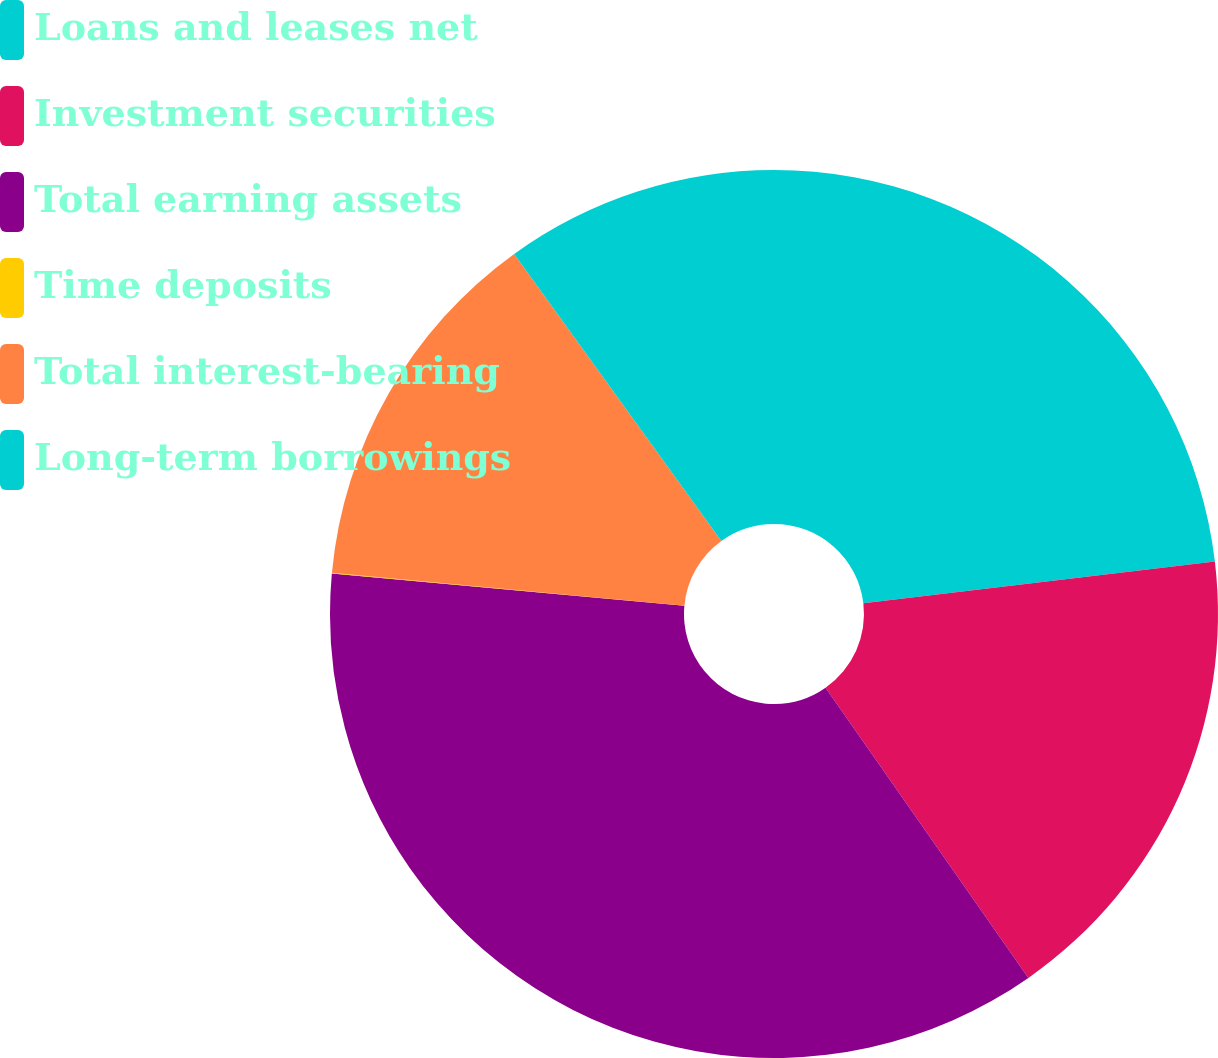Convert chart to OTSL. <chart><loc_0><loc_0><loc_500><loc_500><pie_chart><fcel>Loans and leases net<fcel>Investment securities<fcel>Total earning assets<fcel>Time deposits<fcel>Total interest-bearing<fcel>Long-term borrowings<nl><fcel>23.11%<fcel>17.18%<fcel>36.16%<fcel>0.03%<fcel>13.57%<fcel>9.95%<nl></chart> 